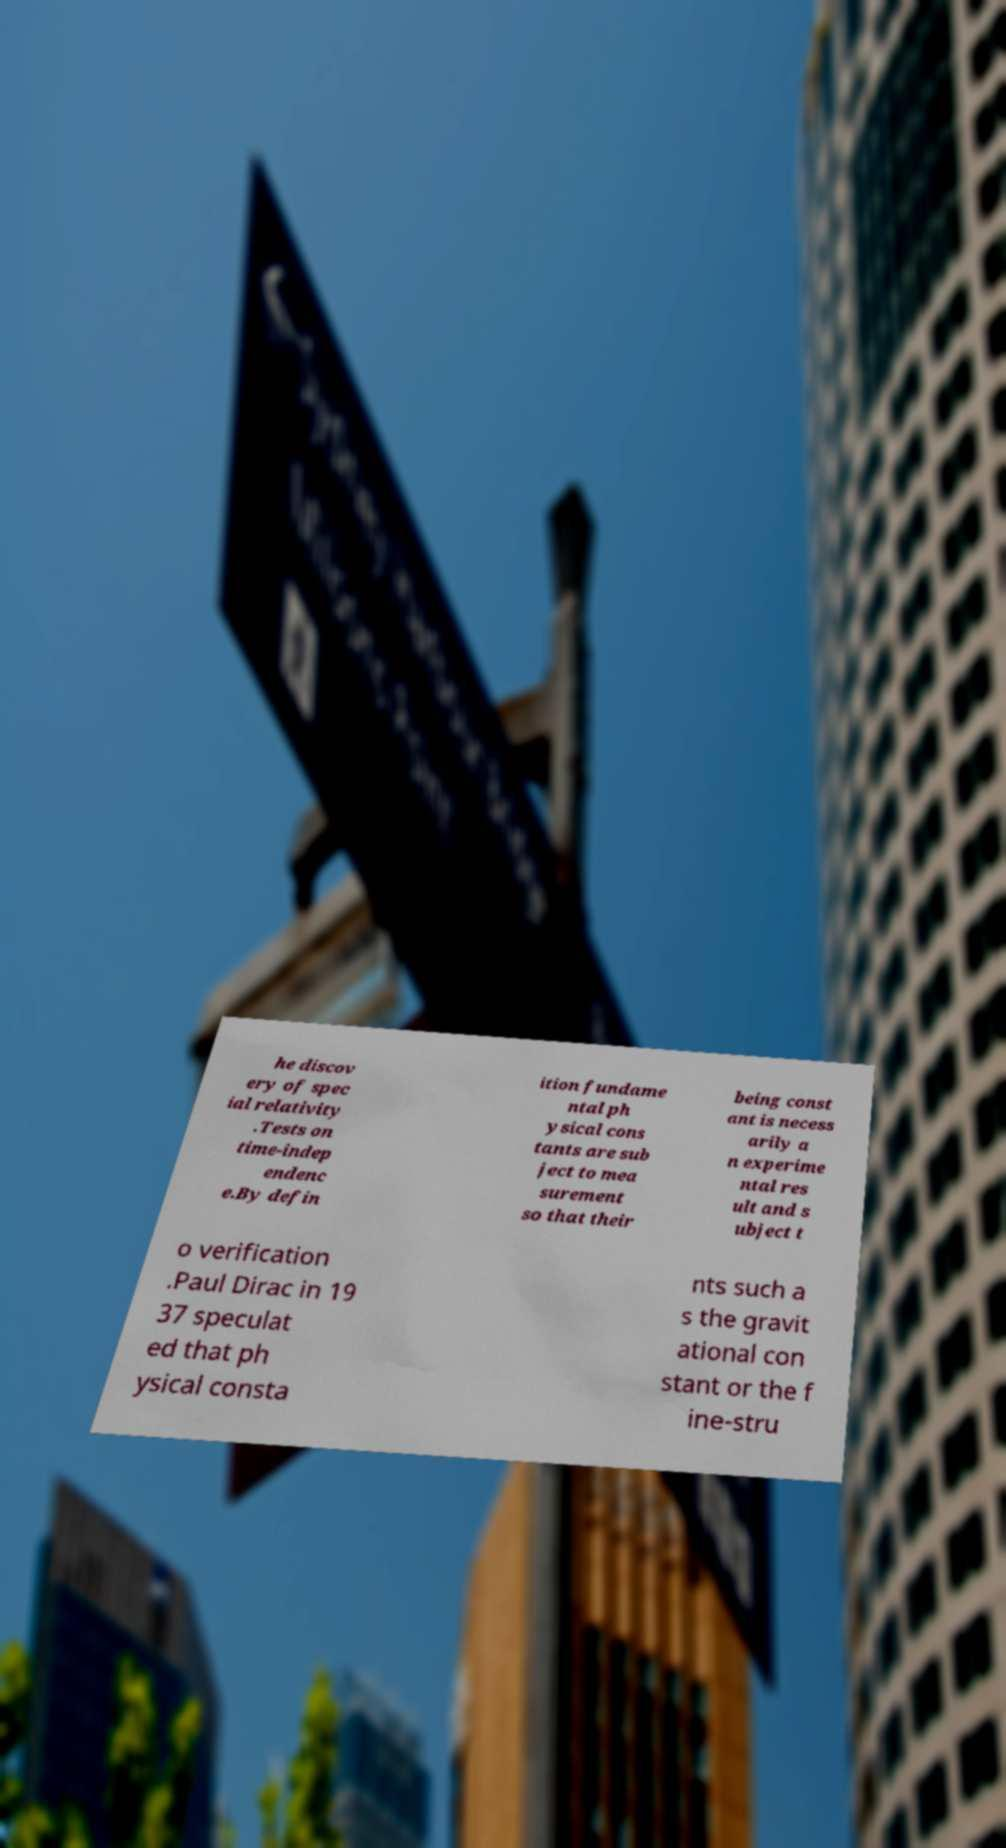Can you read and provide the text displayed in the image?This photo seems to have some interesting text. Can you extract and type it out for me? he discov ery of spec ial relativity .Tests on time-indep endenc e.By defin ition fundame ntal ph ysical cons tants are sub ject to mea surement so that their being const ant is necess arily a n experime ntal res ult and s ubject t o verification .Paul Dirac in 19 37 speculat ed that ph ysical consta nts such a s the gravit ational con stant or the f ine-stru 